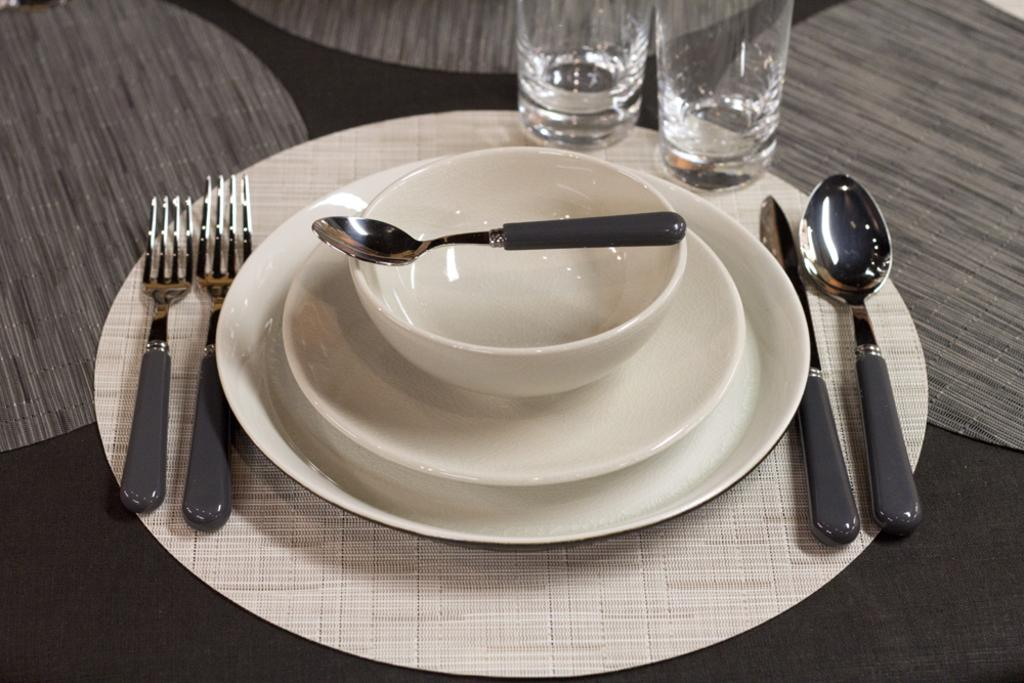What is on the bowl in the image? There is a spoon on a bowl in the image. What can be seen on the table in the image? There are plates on a table in the image. What utensil is present in the image? There is a knife in the image. How many types of utensils can be seen in the image? There are spoons and forks in the image, making a total of two types of utensils. What is used for drinking in the image? There are glasses in the image. What type of quill is being used to write on the cemetery in the image? There is no cemetery or quill present in the image. How many people are trying to crush the glasses in the image? There are no people attempting to crush the glasses in the image. 